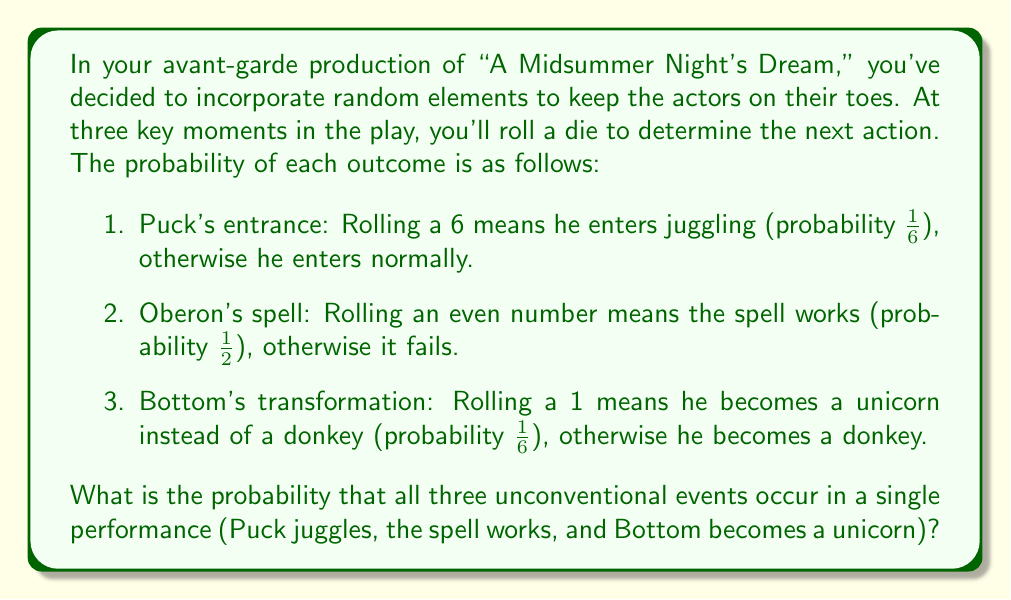Give your solution to this math problem. To solve this problem, we need to use the multiplication rule of probability for independent events. The probability of all these events occurring together is the product of their individual probabilities.

Let's break it down step by step:

1. Probability of Puck entering juggling:
   $P(\text{Puck juggling}) = \frac{1}{6}$

2. Probability of Oberon's spell working:
   $P(\text{Spell working}) = \frac{1}{2}$

3. Probability of Bottom becoming a unicorn:
   $P(\text{Bottom as unicorn}) = \frac{1}{6}$

Now, we multiply these probabilities:

$$P(\text{All events}) = P(\text{Puck juggling}) \times P(\text{Spell working}) \times P(\text{Bottom as unicorn})$$

$$P(\text{All events}) = \frac{1}{6} \times \frac{1}{2} \times \frac{1}{6}$$

$$P(\text{All events}) = \frac{1}{72}$$

Therefore, the probability of all three unconventional events occurring in a single performance is $\frac{1}{72}$.
Answer: $\frac{1}{72}$ 